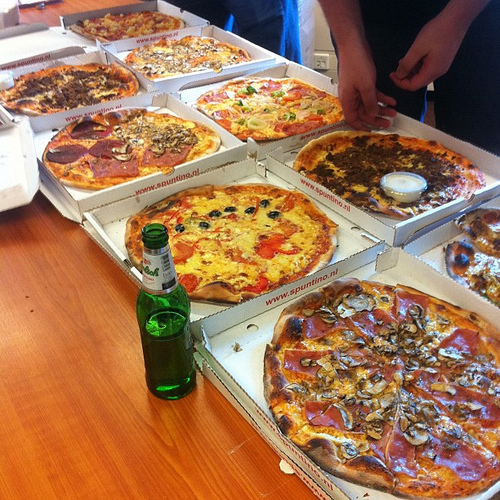Is there any wine to the right of the green bottle? No, there is no wine to the right of the green bottle. 